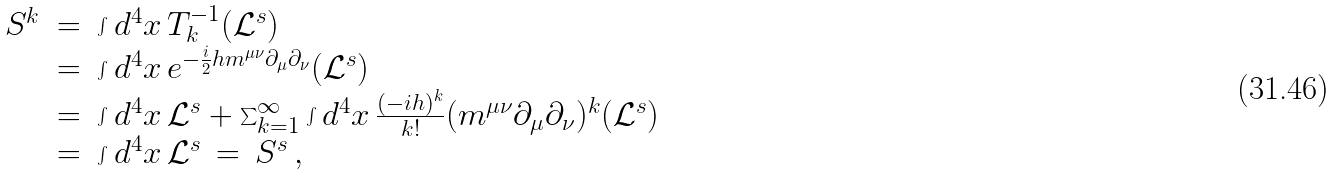<formula> <loc_0><loc_0><loc_500><loc_500>\begin{array} { r c l } S ^ { k } & = & \int d ^ { 4 } x \, T ^ { - 1 } _ { k } ( \mathcal { L } ^ { s } ) \\ & = & \int d ^ { 4 } x \, e ^ { - \frac { i } { 2 } h m ^ { \mu \nu } \partial _ { \mu } \partial _ { \nu } } ( \mathcal { L } ^ { s } ) \\ & = & \int d ^ { 4 } x \, \mathcal { L } ^ { s } + \sum ^ { \infty } _ { k = 1 } \int d ^ { 4 } x \, \frac { ( - i h ) ^ { k } } { k ! } ( m ^ { \mu \nu } \partial _ { \mu } \partial _ { \nu } ) ^ { k } ( \mathcal { L } ^ { s } ) \\ & = & \int d ^ { 4 } x \, \mathcal { L } ^ { s } \, = \, S ^ { s } \, , \end{array}</formula> 